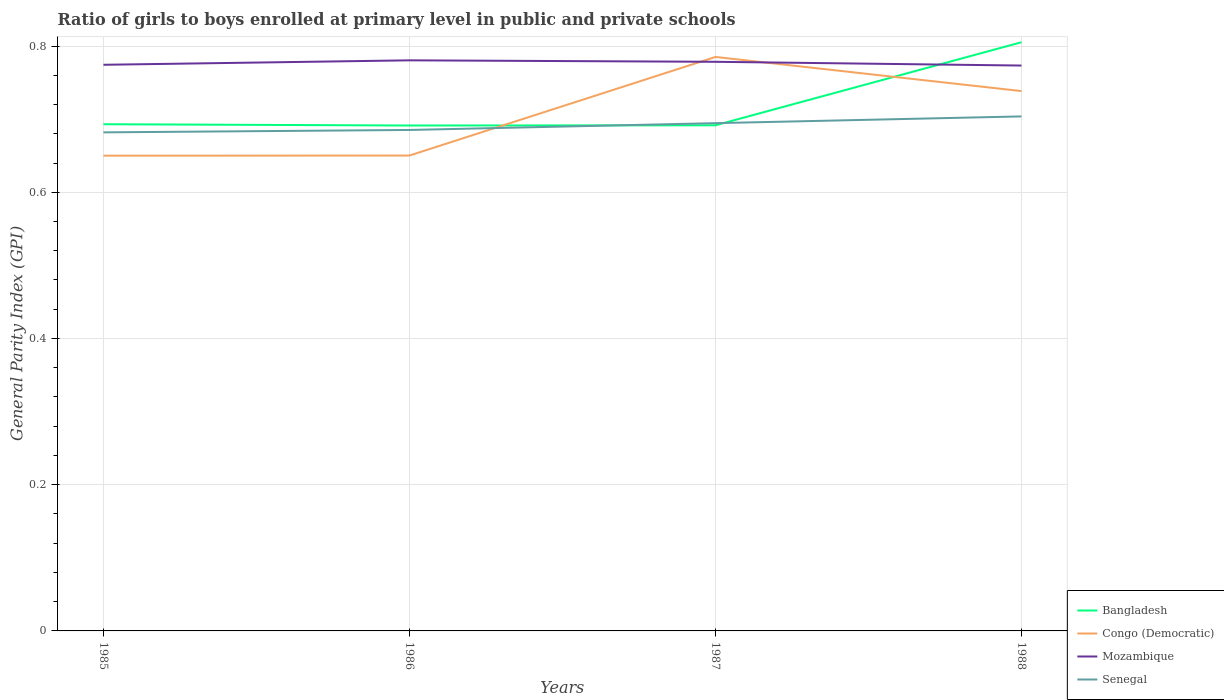How many different coloured lines are there?
Your response must be concise. 4. Does the line corresponding to Senegal intersect with the line corresponding to Congo (Democratic)?
Keep it short and to the point. Yes. Is the number of lines equal to the number of legend labels?
Ensure brevity in your answer.  Yes. Across all years, what is the maximum general parity index in Senegal?
Provide a short and direct response. 0.68. In which year was the general parity index in Bangladesh maximum?
Provide a short and direct response. 1986. What is the total general parity index in Congo (Democratic) in the graph?
Your answer should be compact. -0.14. What is the difference between the highest and the second highest general parity index in Mozambique?
Make the answer very short. 0.01. Is the general parity index in Mozambique strictly greater than the general parity index in Senegal over the years?
Give a very brief answer. No. How many years are there in the graph?
Make the answer very short. 4. Does the graph contain any zero values?
Your answer should be compact. No. Does the graph contain grids?
Offer a terse response. Yes. Where does the legend appear in the graph?
Offer a terse response. Bottom right. What is the title of the graph?
Give a very brief answer. Ratio of girls to boys enrolled at primary level in public and private schools. Does "United Kingdom" appear as one of the legend labels in the graph?
Offer a very short reply. No. What is the label or title of the X-axis?
Offer a terse response. Years. What is the label or title of the Y-axis?
Ensure brevity in your answer.  General Parity Index (GPI). What is the General Parity Index (GPI) in Bangladesh in 1985?
Give a very brief answer. 0.69. What is the General Parity Index (GPI) in Congo (Democratic) in 1985?
Your answer should be compact. 0.65. What is the General Parity Index (GPI) of Mozambique in 1985?
Make the answer very short. 0.77. What is the General Parity Index (GPI) of Senegal in 1985?
Give a very brief answer. 0.68. What is the General Parity Index (GPI) of Bangladesh in 1986?
Provide a short and direct response. 0.69. What is the General Parity Index (GPI) of Congo (Democratic) in 1986?
Offer a terse response. 0.65. What is the General Parity Index (GPI) in Mozambique in 1986?
Provide a succinct answer. 0.78. What is the General Parity Index (GPI) in Senegal in 1986?
Your answer should be compact. 0.69. What is the General Parity Index (GPI) in Bangladesh in 1987?
Your answer should be compact. 0.69. What is the General Parity Index (GPI) in Congo (Democratic) in 1987?
Your answer should be compact. 0.79. What is the General Parity Index (GPI) of Mozambique in 1987?
Your answer should be compact. 0.78. What is the General Parity Index (GPI) in Senegal in 1987?
Your answer should be very brief. 0.69. What is the General Parity Index (GPI) in Bangladesh in 1988?
Give a very brief answer. 0.81. What is the General Parity Index (GPI) in Congo (Democratic) in 1988?
Ensure brevity in your answer.  0.74. What is the General Parity Index (GPI) in Mozambique in 1988?
Make the answer very short. 0.77. What is the General Parity Index (GPI) of Senegal in 1988?
Ensure brevity in your answer.  0.7. Across all years, what is the maximum General Parity Index (GPI) in Bangladesh?
Keep it short and to the point. 0.81. Across all years, what is the maximum General Parity Index (GPI) of Congo (Democratic)?
Give a very brief answer. 0.79. Across all years, what is the maximum General Parity Index (GPI) in Mozambique?
Your answer should be compact. 0.78. Across all years, what is the maximum General Parity Index (GPI) in Senegal?
Make the answer very short. 0.7. Across all years, what is the minimum General Parity Index (GPI) of Bangladesh?
Provide a short and direct response. 0.69. Across all years, what is the minimum General Parity Index (GPI) in Congo (Democratic)?
Provide a short and direct response. 0.65. Across all years, what is the minimum General Parity Index (GPI) of Mozambique?
Ensure brevity in your answer.  0.77. Across all years, what is the minimum General Parity Index (GPI) of Senegal?
Offer a terse response. 0.68. What is the total General Parity Index (GPI) in Bangladesh in the graph?
Make the answer very short. 2.88. What is the total General Parity Index (GPI) of Congo (Democratic) in the graph?
Keep it short and to the point. 2.82. What is the total General Parity Index (GPI) in Mozambique in the graph?
Provide a short and direct response. 3.11. What is the total General Parity Index (GPI) of Senegal in the graph?
Ensure brevity in your answer.  2.77. What is the difference between the General Parity Index (GPI) in Bangladesh in 1985 and that in 1986?
Offer a terse response. 0. What is the difference between the General Parity Index (GPI) of Congo (Democratic) in 1985 and that in 1986?
Ensure brevity in your answer.  -0. What is the difference between the General Parity Index (GPI) in Mozambique in 1985 and that in 1986?
Make the answer very short. -0.01. What is the difference between the General Parity Index (GPI) of Senegal in 1985 and that in 1986?
Your answer should be very brief. -0. What is the difference between the General Parity Index (GPI) of Bangladesh in 1985 and that in 1987?
Offer a very short reply. 0. What is the difference between the General Parity Index (GPI) in Congo (Democratic) in 1985 and that in 1987?
Offer a very short reply. -0.14. What is the difference between the General Parity Index (GPI) of Mozambique in 1985 and that in 1987?
Make the answer very short. -0. What is the difference between the General Parity Index (GPI) in Senegal in 1985 and that in 1987?
Your response must be concise. -0.01. What is the difference between the General Parity Index (GPI) in Bangladesh in 1985 and that in 1988?
Give a very brief answer. -0.11. What is the difference between the General Parity Index (GPI) of Congo (Democratic) in 1985 and that in 1988?
Provide a short and direct response. -0.09. What is the difference between the General Parity Index (GPI) in Senegal in 1985 and that in 1988?
Provide a short and direct response. -0.02. What is the difference between the General Parity Index (GPI) in Bangladesh in 1986 and that in 1987?
Make the answer very short. -0. What is the difference between the General Parity Index (GPI) in Congo (Democratic) in 1986 and that in 1987?
Provide a succinct answer. -0.13. What is the difference between the General Parity Index (GPI) in Mozambique in 1986 and that in 1987?
Offer a terse response. 0. What is the difference between the General Parity Index (GPI) of Senegal in 1986 and that in 1987?
Your response must be concise. -0.01. What is the difference between the General Parity Index (GPI) of Bangladesh in 1986 and that in 1988?
Make the answer very short. -0.11. What is the difference between the General Parity Index (GPI) of Congo (Democratic) in 1986 and that in 1988?
Keep it short and to the point. -0.09. What is the difference between the General Parity Index (GPI) in Mozambique in 1986 and that in 1988?
Provide a succinct answer. 0.01. What is the difference between the General Parity Index (GPI) in Senegal in 1986 and that in 1988?
Ensure brevity in your answer.  -0.02. What is the difference between the General Parity Index (GPI) of Bangladesh in 1987 and that in 1988?
Ensure brevity in your answer.  -0.11. What is the difference between the General Parity Index (GPI) of Congo (Democratic) in 1987 and that in 1988?
Your response must be concise. 0.05. What is the difference between the General Parity Index (GPI) in Mozambique in 1987 and that in 1988?
Keep it short and to the point. 0.01. What is the difference between the General Parity Index (GPI) in Senegal in 1987 and that in 1988?
Your answer should be very brief. -0.01. What is the difference between the General Parity Index (GPI) in Bangladesh in 1985 and the General Parity Index (GPI) in Congo (Democratic) in 1986?
Your answer should be compact. 0.04. What is the difference between the General Parity Index (GPI) of Bangladesh in 1985 and the General Parity Index (GPI) of Mozambique in 1986?
Provide a succinct answer. -0.09. What is the difference between the General Parity Index (GPI) in Bangladesh in 1985 and the General Parity Index (GPI) in Senegal in 1986?
Offer a very short reply. 0.01. What is the difference between the General Parity Index (GPI) of Congo (Democratic) in 1985 and the General Parity Index (GPI) of Mozambique in 1986?
Make the answer very short. -0.13. What is the difference between the General Parity Index (GPI) in Congo (Democratic) in 1985 and the General Parity Index (GPI) in Senegal in 1986?
Your response must be concise. -0.04. What is the difference between the General Parity Index (GPI) in Mozambique in 1985 and the General Parity Index (GPI) in Senegal in 1986?
Make the answer very short. 0.09. What is the difference between the General Parity Index (GPI) of Bangladesh in 1985 and the General Parity Index (GPI) of Congo (Democratic) in 1987?
Your response must be concise. -0.09. What is the difference between the General Parity Index (GPI) in Bangladesh in 1985 and the General Parity Index (GPI) in Mozambique in 1987?
Your answer should be compact. -0.09. What is the difference between the General Parity Index (GPI) of Bangladesh in 1985 and the General Parity Index (GPI) of Senegal in 1987?
Provide a succinct answer. -0. What is the difference between the General Parity Index (GPI) of Congo (Democratic) in 1985 and the General Parity Index (GPI) of Mozambique in 1987?
Provide a short and direct response. -0.13. What is the difference between the General Parity Index (GPI) in Congo (Democratic) in 1985 and the General Parity Index (GPI) in Senegal in 1987?
Your response must be concise. -0.04. What is the difference between the General Parity Index (GPI) of Mozambique in 1985 and the General Parity Index (GPI) of Senegal in 1987?
Your answer should be very brief. 0.08. What is the difference between the General Parity Index (GPI) in Bangladesh in 1985 and the General Parity Index (GPI) in Congo (Democratic) in 1988?
Make the answer very short. -0.05. What is the difference between the General Parity Index (GPI) in Bangladesh in 1985 and the General Parity Index (GPI) in Mozambique in 1988?
Make the answer very short. -0.08. What is the difference between the General Parity Index (GPI) in Bangladesh in 1985 and the General Parity Index (GPI) in Senegal in 1988?
Offer a terse response. -0.01. What is the difference between the General Parity Index (GPI) in Congo (Democratic) in 1985 and the General Parity Index (GPI) in Mozambique in 1988?
Ensure brevity in your answer.  -0.12. What is the difference between the General Parity Index (GPI) in Congo (Democratic) in 1985 and the General Parity Index (GPI) in Senegal in 1988?
Ensure brevity in your answer.  -0.05. What is the difference between the General Parity Index (GPI) of Mozambique in 1985 and the General Parity Index (GPI) of Senegal in 1988?
Provide a succinct answer. 0.07. What is the difference between the General Parity Index (GPI) in Bangladesh in 1986 and the General Parity Index (GPI) in Congo (Democratic) in 1987?
Provide a succinct answer. -0.09. What is the difference between the General Parity Index (GPI) in Bangladesh in 1986 and the General Parity Index (GPI) in Mozambique in 1987?
Your response must be concise. -0.09. What is the difference between the General Parity Index (GPI) in Bangladesh in 1986 and the General Parity Index (GPI) in Senegal in 1987?
Ensure brevity in your answer.  -0. What is the difference between the General Parity Index (GPI) of Congo (Democratic) in 1986 and the General Parity Index (GPI) of Mozambique in 1987?
Give a very brief answer. -0.13. What is the difference between the General Parity Index (GPI) in Congo (Democratic) in 1986 and the General Parity Index (GPI) in Senegal in 1987?
Offer a very short reply. -0.04. What is the difference between the General Parity Index (GPI) of Mozambique in 1986 and the General Parity Index (GPI) of Senegal in 1987?
Your answer should be very brief. 0.09. What is the difference between the General Parity Index (GPI) in Bangladesh in 1986 and the General Parity Index (GPI) in Congo (Democratic) in 1988?
Provide a short and direct response. -0.05. What is the difference between the General Parity Index (GPI) in Bangladesh in 1986 and the General Parity Index (GPI) in Mozambique in 1988?
Make the answer very short. -0.08. What is the difference between the General Parity Index (GPI) of Bangladesh in 1986 and the General Parity Index (GPI) of Senegal in 1988?
Your answer should be very brief. -0.01. What is the difference between the General Parity Index (GPI) of Congo (Democratic) in 1986 and the General Parity Index (GPI) of Mozambique in 1988?
Offer a terse response. -0.12. What is the difference between the General Parity Index (GPI) in Congo (Democratic) in 1986 and the General Parity Index (GPI) in Senegal in 1988?
Make the answer very short. -0.05. What is the difference between the General Parity Index (GPI) in Mozambique in 1986 and the General Parity Index (GPI) in Senegal in 1988?
Give a very brief answer. 0.08. What is the difference between the General Parity Index (GPI) of Bangladesh in 1987 and the General Parity Index (GPI) of Congo (Democratic) in 1988?
Make the answer very short. -0.05. What is the difference between the General Parity Index (GPI) of Bangladesh in 1987 and the General Parity Index (GPI) of Mozambique in 1988?
Make the answer very short. -0.08. What is the difference between the General Parity Index (GPI) of Bangladesh in 1987 and the General Parity Index (GPI) of Senegal in 1988?
Provide a short and direct response. -0.01. What is the difference between the General Parity Index (GPI) in Congo (Democratic) in 1987 and the General Parity Index (GPI) in Mozambique in 1988?
Provide a succinct answer. 0.01. What is the difference between the General Parity Index (GPI) of Congo (Democratic) in 1987 and the General Parity Index (GPI) of Senegal in 1988?
Your answer should be very brief. 0.08. What is the difference between the General Parity Index (GPI) of Mozambique in 1987 and the General Parity Index (GPI) of Senegal in 1988?
Your response must be concise. 0.07. What is the average General Parity Index (GPI) in Bangladesh per year?
Give a very brief answer. 0.72. What is the average General Parity Index (GPI) in Congo (Democratic) per year?
Offer a very short reply. 0.71. What is the average General Parity Index (GPI) of Mozambique per year?
Ensure brevity in your answer.  0.78. What is the average General Parity Index (GPI) of Senegal per year?
Offer a terse response. 0.69. In the year 1985, what is the difference between the General Parity Index (GPI) of Bangladesh and General Parity Index (GPI) of Congo (Democratic)?
Offer a terse response. 0.04. In the year 1985, what is the difference between the General Parity Index (GPI) in Bangladesh and General Parity Index (GPI) in Mozambique?
Your answer should be very brief. -0.08. In the year 1985, what is the difference between the General Parity Index (GPI) of Bangladesh and General Parity Index (GPI) of Senegal?
Your answer should be very brief. 0.01. In the year 1985, what is the difference between the General Parity Index (GPI) in Congo (Democratic) and General Parity Index (GPI) in Mozambique?
Make the answer very short. -0.12. In the year 1985, what is the difference between the General Parity Index (GPI) in Congo (Democratic) and General Parity Index (GPI) in Senegal?
Your answer should be compact. -0.03. In the year 1985, what is the difference between the General Parity Index (GPI) in Mozambique and General Parity Index (GPI) in Senegal?
Ensure brevity in your answer.  0.09. In the year 1986, what is the difference between the General Parity Index (GPI) in Bangladesh and General Parity Index (GPI) in Congo (Democratic)?
Provide a short and direct response. 0.04. In the year 1986, what is the difference between the General Parity Index (GPI) of Bangladesh and General Parity Index (GPI) of Mozambique?
Your answer should be compact. -0.09. In the year 1986, what is the difference between the General Parity Index (GPI) in Bangladesh and General Parity Index (GPI) in Senegal?
Ensure brevity in your answer.  0.01. In the year 1986, what is the difference between the General Parity Index (GPI) in Congo (Democratic) and General Parity Index (GPI) in Mozambique?
Your response must be concise. -0.13. In the year 1986, what is the difference between the General Parity Index (GPI) of Congo (Democratic) and General Parity Index (GPI) of Senegal?
Provide a short and direct response. -0.04. In the year 1986, what is the difference between the General Parity Index (GPI) of Mozambique and General Parity Index (GPI) of Senegal?
Give a very brief answer. 0.1. In the year 1987, what is the difference between the General Parity Index (GPI) of Bangladesh and General Parity Index (GPI) of Congo (Democratic)?
Provide a succinct answer. -0.09. In the year 1987, what is the difference between the General Parity Index (GPI) in Bangladesh and General Parity Index (GPI) in Mozambique?
Provide a succinct answer. -0.09. In the year 1987, what is the difference between the General Parity Index (GPI) in Bangladesh and General Parity Index (GPI) in Senegal?
Your answer should be compact. -0. In the year 1987, what is the difference between the General Parity Index (GPI) in Congo (Democratic) and General Parity Index (GPI) in Mozambique?
Your response must be concise. 0.01. In the year 1987, what is the difference between the General Parity Index (GPI) in Congo (Democratic) and General Parity Index (GPI) in Senegal?
Offer a terse response. 0.09. In the year 1987, what is the difference between the General Parity Index (GPI) in Mozambique and General Parity Index (GPI) in Senegal?
Make the answer very short. 0.08. In the year 1988, what is the difference between the General Parity Index (GPI) in Bangladesh and General Parity Index (GPI) in Congo (Democratic)?
Your answer should be very brief. 0.07. In the year 1988, what is the difference between the General Parity Index (GPI) of Bangladesh and General Parity Index (GPI) of Mozambique?
Offer a terse response. 0.03. In the year 1988, what is the difference between the General Parity Index (GPI) in Bangladesh and General Parity Index (GPI) in Senegal?
Offer a terse response. 0.1. In the year 1988, what is the difference between the General Parity Index (GPI) of Congo (Democratic) and General Parity Index (GPI) of Mozambique?
Provide a short and direct response. -0.03. In the year 1988, what is the difference between the General Parity Index (GPI) of Congo (Democratic) and General Parity Index (GPI) of Senegal?
Ensure brevity in your answer.  0.03. In the year 1988, what is the difference between the General Parity Index (GPI) of Mozambique and General Parity Index (GPI) of Senegal?
Keep it short and to the point. 0.07. What is the ratio of the General Parity Index (GPI) in Bangladesh in 1985 to that in 1986?
Offer a terse response. 1. What is the ratio of the General Parity Index (GPI) of Congo (Democratic) in 1985 to that in 1986?
Keep it short and to the point. 1. What is the ratio of the General Parity Index (GPI) of Mozambique in 1985 to that in 1986?
Provide a succinct answer. 0.99. What is the ratio of the General Parity Index (GPI) in Congo (Democratic) in 1985 to that in 1987?
Provide a succinct answer. 0.83. What is the ratio of the General Parity Index (GPI) in Mozambique in 1985 to that in 1987?
Provide a short and direct response. 0.99. What is the ratio of the General Parity Index (GPI) in Senegal in 1985 to that in 1987?
Give a very brief answer. 0.98. What is the ratio of the General Parity Index (GPI) in Bangladesh in 1985 to that in 1988?
Give a very brief answer. 0.86. What is the ratio of the General Parity Index (GPI) in Congo (Democratic) in 1985 to that in 1988?
Ensure brevity in your answer.  0.88. What is the ratio of the General Parity Index (GPI) in Mozambique in 1985 to that in 1988?
Your answer should be very brief. 1. What is the ratio of the General Parity Index (GPI) of Bangladesh in 1986 to that in 1987?
Your response must be concise. 1. What is the ratio of the General Parity Index (GPI) in Congo (Democratic) in 1986 to that in 1987?
Give a very brief answer. 0.83. What is the ratio of the General Parity Index (GPI) in Mozambique in 1986 to that in 1987?
Make the answer very short. 1. What is the ratio of the General Parity Index (GPI) in Senegal in 1986 to that in 1987?
Offer a very short reply. 0.99. What is the ratio of the General Parity Index (GPI) of Bangladesh in 1986 to that in 1988?
Make the answer very short. 0.86. What is the ratio of the General Parity Index (GPI) in Congo (Democratic) in 1986 to that in 1988?
Your answer should be very brief. 0.88. What is the ratio of the General Parity Index (GPI) in Mozambique in 1986 to that in 1988?
Make the answer very short. 1.01. What is the ratio of the General Parity Index (GPI) of Senegal in 1986 to that in 1988?
Provide a succinct answer. 0.97. What is the ratio of the General Parity Index (GPI) of Bangladesh in 1987 to that in 1988?
Give a very brief answer. 0.86. What is the ratio of the General Parity Index (GPI) of Congo (Democratic) in 1987 to that in 1988?
Keep it short and to the point. 1.06. What is the ratio of the General Parity Index (GPI) in Mozambique in 1987 to that in 1988?
Your response must be concise. 1.01. What is the ratio of the General Parity Index (GPI) of Senegal in 1987 to that in 1988?
Offer a terse response. 0.99. What is the difference between the highest and the second highest General Parity Index (GPI) in Bangladesh?
Provide a short and direct response. 0.11. What is the difference between the highest and the second highest General Parity Index (GPI) in Congo (Democratic)?
Your response must be concise. 0.05. What is the difference between the highest and the second highest General Parity Index (GPI) of Mozambique?
Your answer should be compact. 0. What is the difference between the highest and the second highest General Parity Index (GPI) of Senegal?
Offer a very short reply. 0.01. What is the difference between the highest and the lowest General Parity Index (GPI) of Bangladesh?
Offer a terse response. 0.11. What is the difference between the highest and the lowest General Parity Index (GPI) of Congo (Democratic)?
Offer a terse response. 0.14. What is the difference between the highest and the lowest General Parity Index (GPI) in Mozambique?
Give a very brief answer. 0.01. What is the difference between the highest and the lowest General Parity Index (GPI) in Senegal?
Your answer should be very brief. 0.02. 